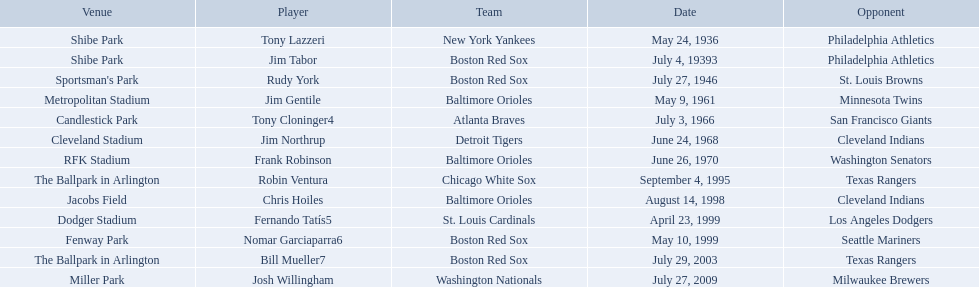Parse the table in full. {'header': ['Venue', 'Player', 'Team', 'Date', 'Opponent'], 'rows': [['Shibe Park', 'Tony Lazzeri', 'New York Yankees', 'May 24, 1936', 'Philadelphia Athletics'], ['Shibe Park', 'Jim Tabor', 'Boston Red Sox', 'July 4, 19393', 'Philadelphia Athletics'], ["Sportsman's Park", 'Rudy York', 'Boston Red Sox', 'July 27, 1946', 'St. Louis Browns'], ['Metropolitan Stadium', 'Jim Gentile', 'Baltimore Orioles', 'May 9, 1961', 'Minnesota Twins'], ['Candlestick Park', 'Tony Cloninger4', 'Atlanta Braves', 'July 3, 1966', 'San Francisco Giants'], ['Cleveland Stadium', 'Jim Northrup', 'Detroit Tigers', 'June 24, 1968', 'Cleveland Indians'], ['RFK Stadium', 'Frank Robinson', 'Baltimore Orioles', 'June 26, 1970', 'Washington Senators'], ['The Ballpark in Arlington', 'Robin Ventura', 'Chicago White Sox', 'September 4, 1995', 'Texas Rangers'], ['Jacobs Field', 'Chris Hoiles', 'Baltimore Orioles', 'August 14, 1998', 'Cleveland Indians'], ['Dodger Stadium', 'Fernando Tatís5', 'St. Louis Cardinals', 'April 23, 1999', 'Los Angeles Dodgers'], ['Fenway Park', 'Nomar Garciaparra6', 'Boston Red Sox', 'May 10, 1999', 'Seattle Mariners'], ['The Ballpark in Arlington', 'Bill Mueller7', 'Boston Red Sox', 'July 29, 2003', 'Texas Rangers'], ['Miller Park', 'Josh Willingham', 'Washington Nationals', 'July 27, 2009', 'Milwaukee Brewers']]} Which teams played between the years 1960 and 1970? Baltimore Orioles, Atlanta Braves, Detroit Tigers, Baltimore Orioles. Of these teams that played, which ones played against the cleveland indians? Detroit Tigers. On what day did these two teams play? June 24, 1968. Who were all of the players? Tony Lazzeri, Jim Tabor, Rudy York, Jim Gentile, Tony Cloninger4, Jim Northrup, Frank Robinson, Robin Ventura, Chris Hoiles, Fernando Tatís5, Nomar Garciaparra6, Bill Mueller7, Josh Willingham. What year was there a player for the yankees? May 24, 1936. Would you be able to parse every entry in this table? {'header': ['Venue', 'Player', 'Team', 'Date', 'Opponent'], 'rows': [['Shibe Park', 'Tony Lazzeri', 'New York Yankees', 'May 24, 1936', 'Philadelphia Athletics'], ['Shibe Park', 'Jim Tabor', 'Boston Red Sox', 'July 4, 19393', 'Philadelphia Athletics'], ["Sportsman's Park", 'Rudy York', 'Boston Red Sox', 'July 27, 1946', 'St. Louis Browns'], ['Metropolitan Stadium', 'Jim Gentile', 'Baltimore Orioles', 'May 9, 1961', 'Minnesota Twins'], ['Candlestick Park', 'Tony Cloninger4', 'Atlanta Braves', 'July 3, 1966', 'San Francisco Giants'], ['Cleveland Stadium', 'Jim Northrup', 'Detroit Tigers', 'June 24, 1968', 'Cleveland Indians'], ['RFK Stadium', 'Frank Robinson', 'Baltimore Orioles', 'June 26, 1970', 'Washington Senators'], ['The Ballpark in Arlington', 'Robin Ventura', 'Chicago White Sox', 'September 4, 1995', 'Texas Rangers'], ['Jacobs Field', 'Chris Hoiles', 'Baltimore Orioles', 'August 14, 1998', 'Cleveland Indians'], ['Dodger Stadium', 'Fernando Tatís5', 'St. Louis Cardinals', 'April 23, 1999', 'Los Angeles Dodgers'], ['Fenway Park', 'Nomar Garciaparra6', 'Boston Red Sox', 'May 10, 1999', 'Seattle Mariners'], ['The Ballpark in Arlington', 'Bill Mueller7', 'Boston Red Sox', 'July 29, 2003', 'Texas Rangers'], ['Miller Park', 'Josh Willingham', 'Washington Nationals', 'July 27, 2009', 'Milwaukee Brewers']]} What was the name of that 1936 yankees player? Tony Lazzeri. 